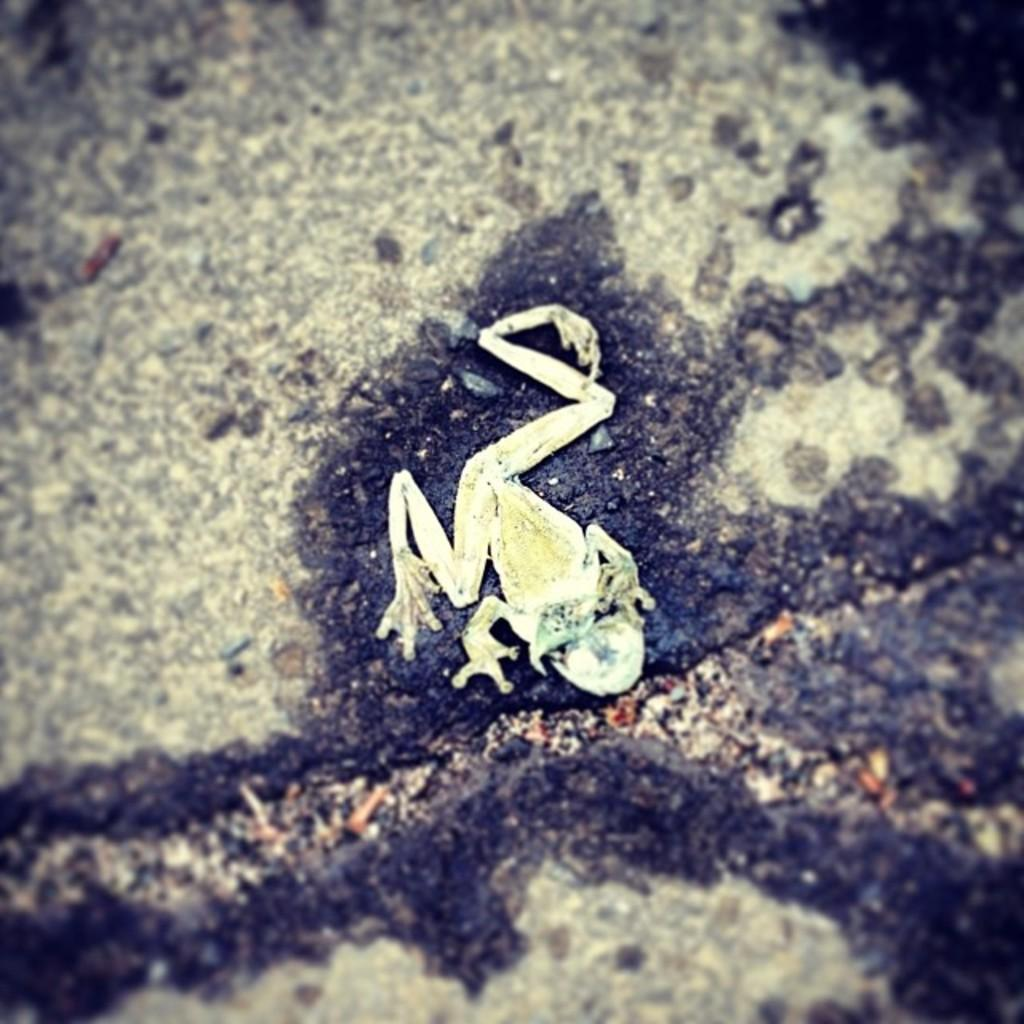What animal is present in the image? There is a frog in the image. What is the frog sitting on? The frog is on a stone. What type of ball is being used by the army in the image? There is no ball or army present in the image; it features a frog on a stone. What kind of cloth is draped over the frog in the image? There is no cloth present in the image; the frog is simply sitting on a stone. 